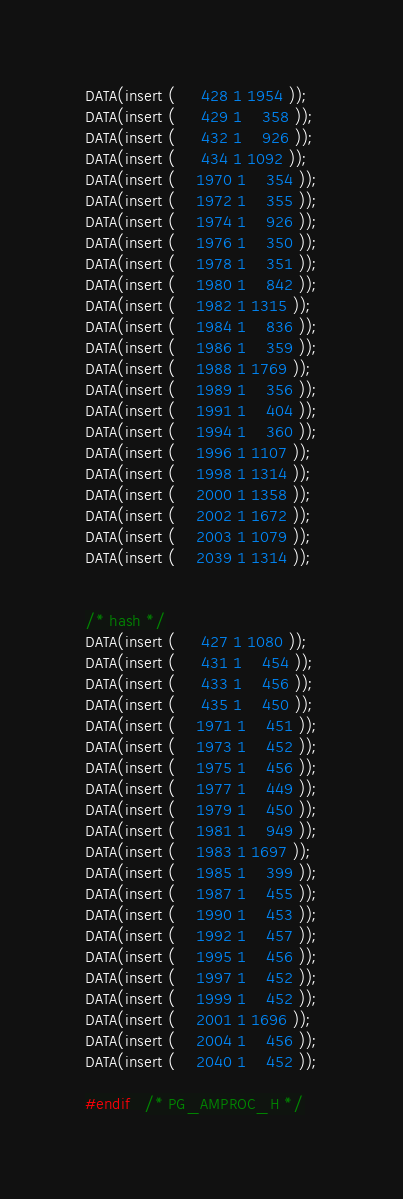Convert code to text. <code><loc_0><loc_0><loc_500><loc_500><_C_>DATA(insert (	 428 1 1954 ));
DATA(insert (	 429 1	358 ));
DATA(insert (	 432 1	926 ));
DATA(insert (	 434 1 1092 ));
DATA(insert (	1970 1	354 ));
DATA(insert (	1972 1	355 ));
DATA(insert (	1974 1	926 ));
DATA(insert (	1976 1	350 ));
DATA(insert (	1978 1	351 ));
DATA(insert (	1980 1	842 ));
DATA(insert (	1982 1 1315 ));
DATA(insert (	1984 1	836 ));
DATA(insert (	1986 1	359 ));
DATA(insert (	1988 1 1769 ));
DATA(insert (	1989 1	356 ));
DATA(insert (	1991 1	404 ));
DATA(insert (	1994 1	360 ));
DATA(insert (	1996 1 1107 ));
DATA(insert (	1998 1 1314 ));
DATA(insert (	2000 1 1358 ));
DATA(insert (	2002 1 1672 ));
DATA(insert (	2003 1 1079 ));
DATA(insert (	2039 1 1314 ));


/* hash */
DATA(insert (	 427 1 1080 ));
DATA(insert (	 431 1	454 ));
DATA(insert (	 433 1	456 ));
DATA(insert (	 435 1	450 ));
DATA(insert (	1971 1	451 ));
DATA(insert (	1973 1	452 ));
DATA(insert (	1975 1	456 ));
DATA(insert (	1977 1	449 ));
DATA(insert (	1979 1	450 ));
DATA(insert (	1981 1	949 ));
DATA(insert (	1983 1 1697 ));
DATA(insert (	1985 1	399 ));
DATA(insert (	1987 1	455 ));
DATA(insert (	1990 1	453 ));
DATA(insert (	1992 1	457 ));
DATA(insert (	1995 1	456 ));
DATA(insert (	1997 1	452 ));
DATA(insert (	1999 1	452 ));
DATA(insert (	2001 1 1696 ));
DATA(insert (	2004 1	456 ));
DATA(insert (	2040 1	452 ));

#endif   /* PG_AMPROC_H */
</code> 